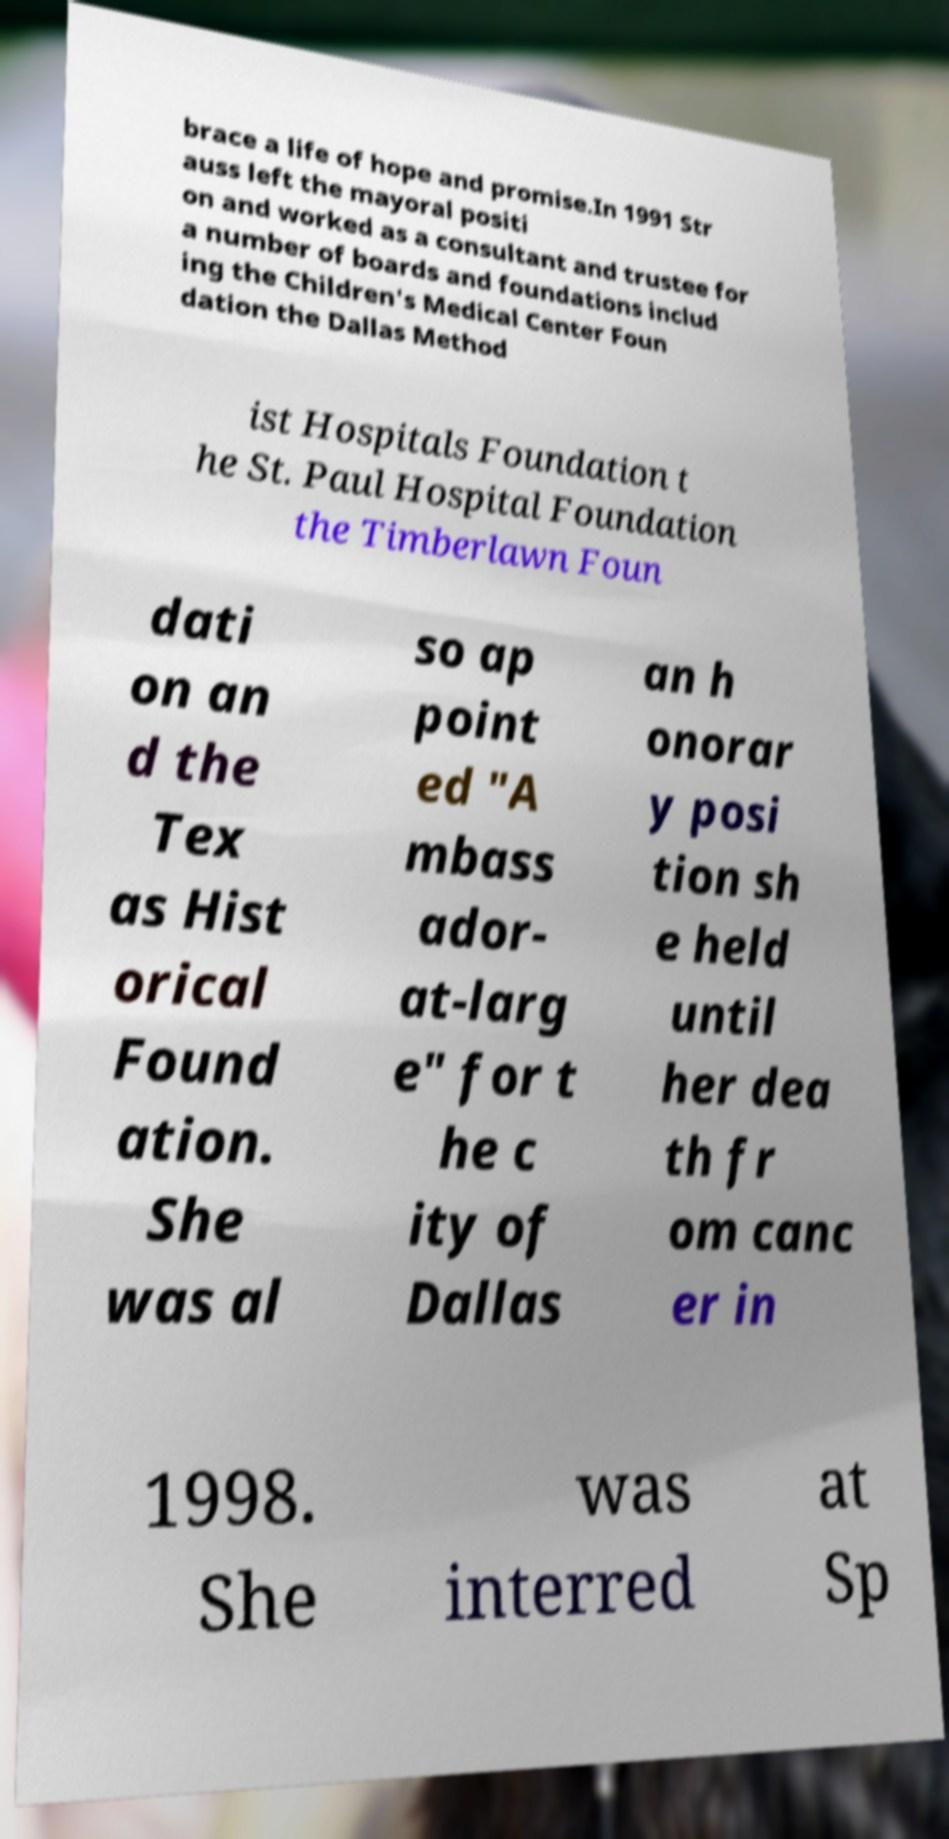There's text embedded in this image that I need extracted. Can you transcribe it verbatim? brace a life of hope and promise.In 1991 Str auss left the mayoral positi on and worked as a consultant and trustee for a number of boards and foundations includ ing the Children's Medical Center Foun dation the Dallas Method ist Hospitals Foundation t he St. Paul Hospital Foundation the Timberlawn Foun dati on an d the Tex as Hist orical Found ation. She was al so ap point ed "A mbass ador- at-larg e" for t he c ity of Dallas an h onorar y posi tion sh e held until her dea th fr om canc er in 1998. She was interred at Sp 